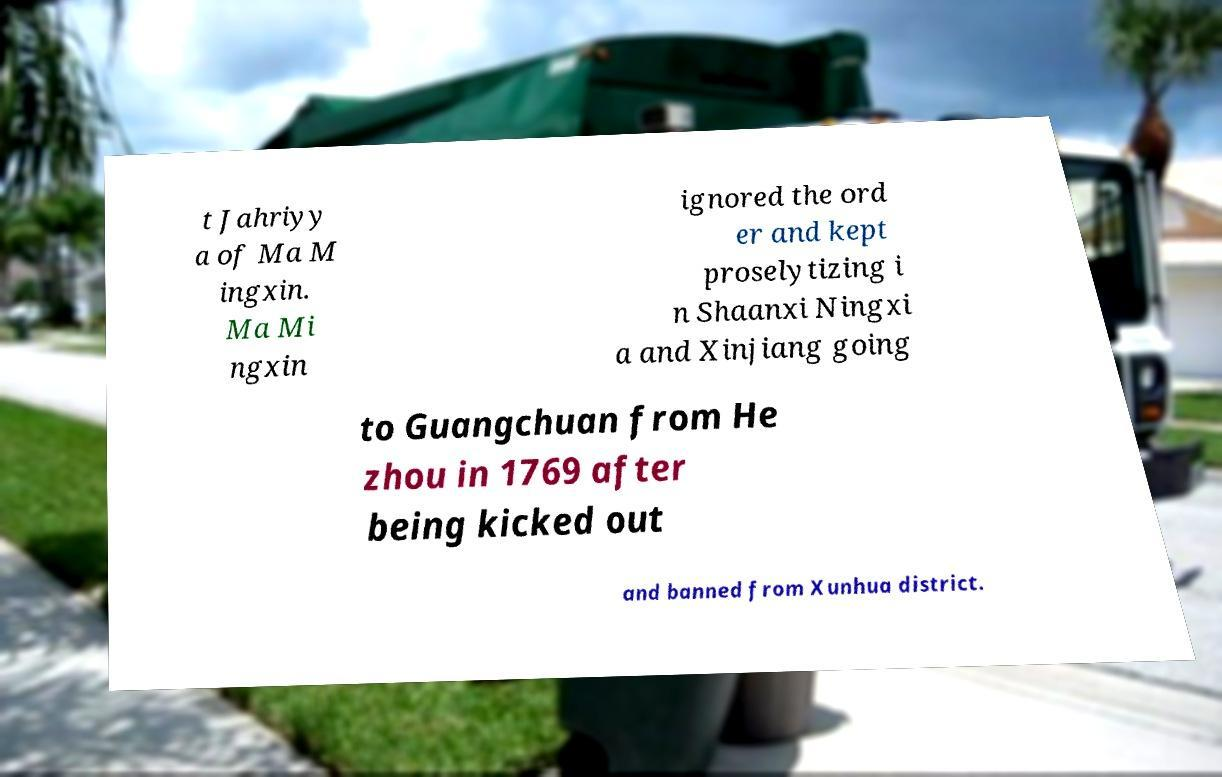Can you read and provide the text displayed in the image?This photo seems to have some interesting text. Can you extract and type it out for me? t Jahriyy a of Ma M ingxin. Ma Mi ngxin ignored the ord er and kept proselytizing i n Shaanxi Ningxi a and Xinjiang going to Guangchuan from He zhou in 1769 after being kicked out and banned from Xunhua district. 